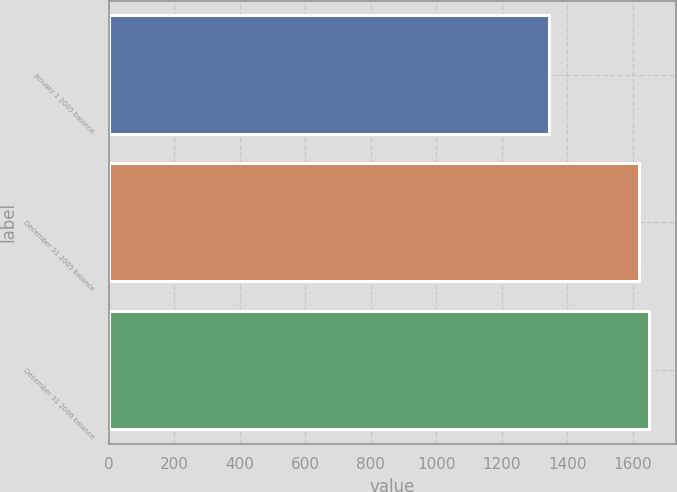Convert chart. <chart><loc_0><loc_0><loc_500><loc_500><bar_chart><fcel>January 1 2005 balance<fcel>December 31 2005 balance<fcel>December 31 2006 balance<nl><fcel>1343.6<fcel>1618<fcel>1648.44<nl></chart> 